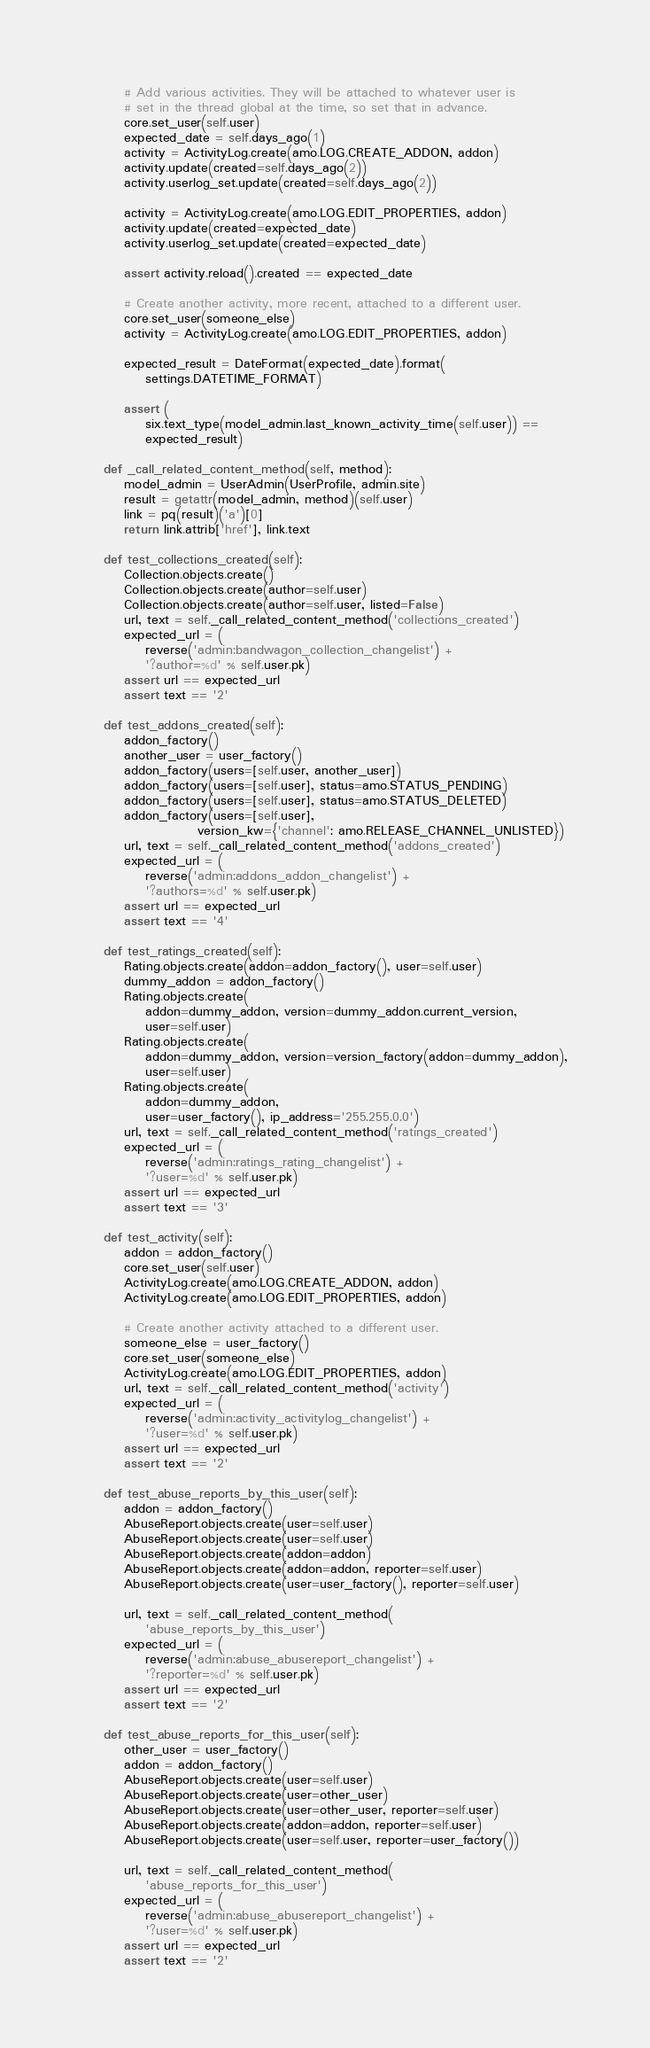Convert code to text. <code><loc_0><loc_0><loc_500><loc_500><_Python_>
        # Add various activities. They will be attached to whatever user is
        # set in the thread global at the time, so set that in advance.
        core.set_user(self.user)
        expected_date = self.days_ago(1)
        activity = ActivityLog.create(amo.LOG.CREATE_ADDON, addon)
        activity.update(created=self.days_ago(2))
        activity.userlog_set.update(created=self.days_ago(2))

        activity = ActivityLog.create(amo.LOG.EDIT_PROPERTIES, addon)
        activity.update(created=expected_date)
        activity.userlog_set.update(created=expected_date)

        assert activity.reload().created == expected_date

        # Create another activity, more recent, attached to a different user.
        core.set_user(someone_else)
        activity = ActivityLog.create(amo.LOG.EDIT_PROPERTIES, addon)

        expected_result = DateFormat(expected_date).format(
            settings.DATETIME_FORMAT)

        assert (
            six.text_type(model_admin.last_known_activity_time(self.user)) ==
            expected_result)

    def _call_related_content_method(self, method):
        model_admin = UserAdmin(UserProfile, admin.site)
        result = getattr(model_admin, method)(self.user)
        link = pq(result)('a')[0]
        return link.attrib['href'], link.text

    def test_collections_created(self):
        Collection.objects.create()
        Collection.objects.create(author=self.user)
        Collection.objects.create(author=self.user, listed=False)
        url, text = self._call_related_content_method('collections_created')
        expected_url = (
            reverse('admin:bandwagon_collection_changelist') +
            '?author=%d' % self.user.pk)
        assert url == expected_url
        assert text == '2'

    def test_addons_created(self):
        addon_factory()
        another_user = user_factory()
        addon_factory(users=[self.user, another_user])
        addon_factory(users=[self.user], status=amo.STATUS_PENDING)
        addon_factory(users=[self.user], status=amo.STATUS_DELETED)
        addon_factory(users=[self.user],
                      version_kw={'channel': amo.RELEASE_CHANNEL_UNLISTED})
        url, text = self._call_related_content_method('addons_created')
        expected_url = (
            reverse('admin:addons_addon_changelist') +
            '?authors=%d' % self.user.pk)
        assert url == expected_url
        assert text == '4'

    def test_ratings_created(self):
        Rating.objects.create(addon=addon_factory(), user=self.user)
        dummy_addon = addon_factory()
        Rating.objects.create(
            addon=dummy_addon, version=dummy_addon.current_version,
            user=self.user)
        Rating.objects.create(
            addon=dummy_addon, version=version_factory(addon=dummy_addon),
            user=self.user)
        Rating.objects.create(
            addon=dummy_addon,
            user=user_factory(), ip_address='255.255.0.0')
        url, text = self._call_related_content_method('ratings_created')
        expected_url = (
            reverse('admin:ratings_rating_changelist') +
            '?user=%d' % self.user.pk)
        assert url == expected_url
        assert text == '3'

    def test_activity(self):
        addon = addon_factory()
        core.set_user(self.user)
        ActivityLog.create(amo.LOG.CREATE_ADDON, addon)
        ActivityLog.create(amo.LOG.EDIT_PROPERTIES, addon)

        # Create another activity attached to a different user.
        someone_else = user_factory()
        core.set_user(someone_else)
        ActivityLog.create(amo.LOG.EDIT_PROPERTIES, addon)
        url, text = self._call_related_content_method('activity')
        expected_url = (
            reverse('admin:activity_activitylog_changelist') +
            '?user=%d' % self.user.pk)
        assert url == expected_url
        assert text == '2'

    def test_abuse_reports_by_this_user(self):
        addon = addon_factory()
        AbuseReport.objects.create(user=self.user)
        AbuseReport.objects.create(user=self.user)
        AbuseReport.objects.create(addon=addon)
        AbuseReport.objects.create(addon=addon, reporter=self.user)
        AbuseReport.objects.create(user=user_factory(), reporter=self.user)

        url, text = self._call_related_content_method(
            'abuse_reports_by_this_user')
        expected_url = (
            reverse('admin:abuse_abusereport_changelist') +
            '?reporter=%d' % self.user.pk)
        assert url == expected_url
        assert text == '2'

    def test_abuse_reports_for_this_user(self):
        other_user = user_factory()
        addon = addon_factory()
        AbuseReport.objects.create(user=self.user)
        AbuseReport.objects.create(user=other_user)
        AbuseReport.objects.create(user=other_user, reporter=self.user)
        AbuseReport.objects.create(addon=addon, reporter=self.user)
        AbuseReport.objects.create(user=self.user, reporter=user_factory())

        url, text = self._call_related_content_method(
            'abuse_reports_for_this_user')
        expected_url = (
            reverse('admin:abuse_abusereport_changelist') +
            '?user=%d' % self.user.pk)
        assert url == expected_url
        assert text == '2'
</code> 